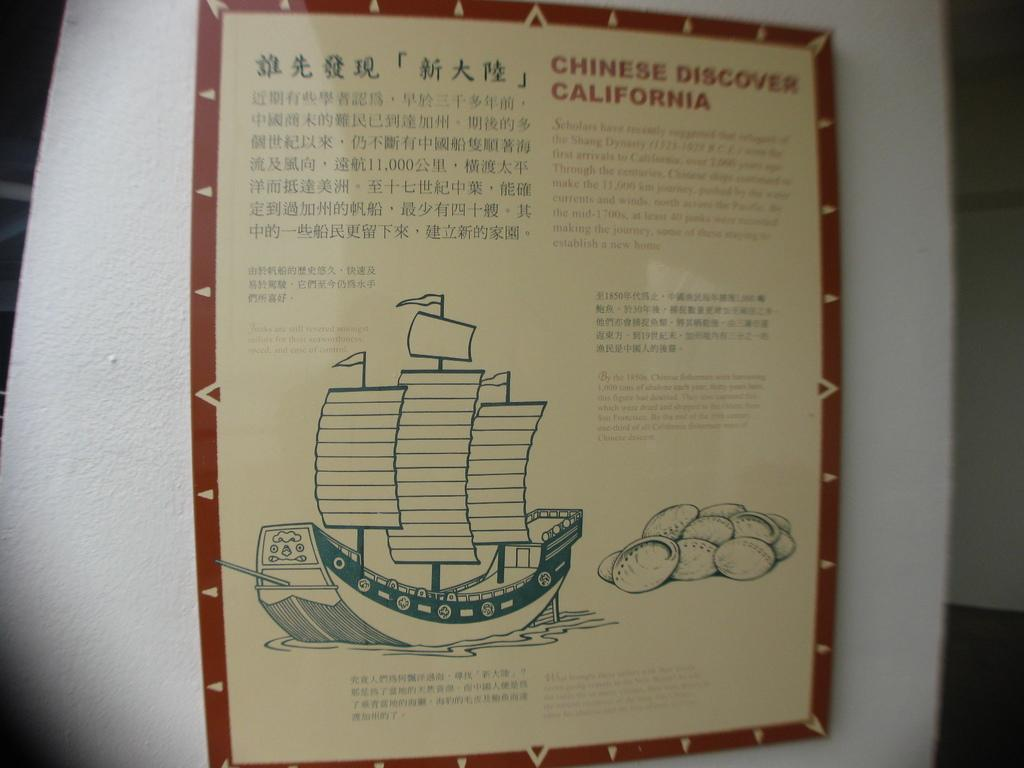What is on the wall in the image? There is a board on the wall. What is depicted on the board? There is a picture of a boat on the board. What type of yard is visible in the image? There is no yard visible in the image; it only features a board with a picture of a boat on it. How far does the pan stretch in the image? There is no pan present in the image. 